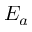Convert formula to latex. <formula><loc_0><loc_0><loc_500><loc_500>E _ { a }</formula> 